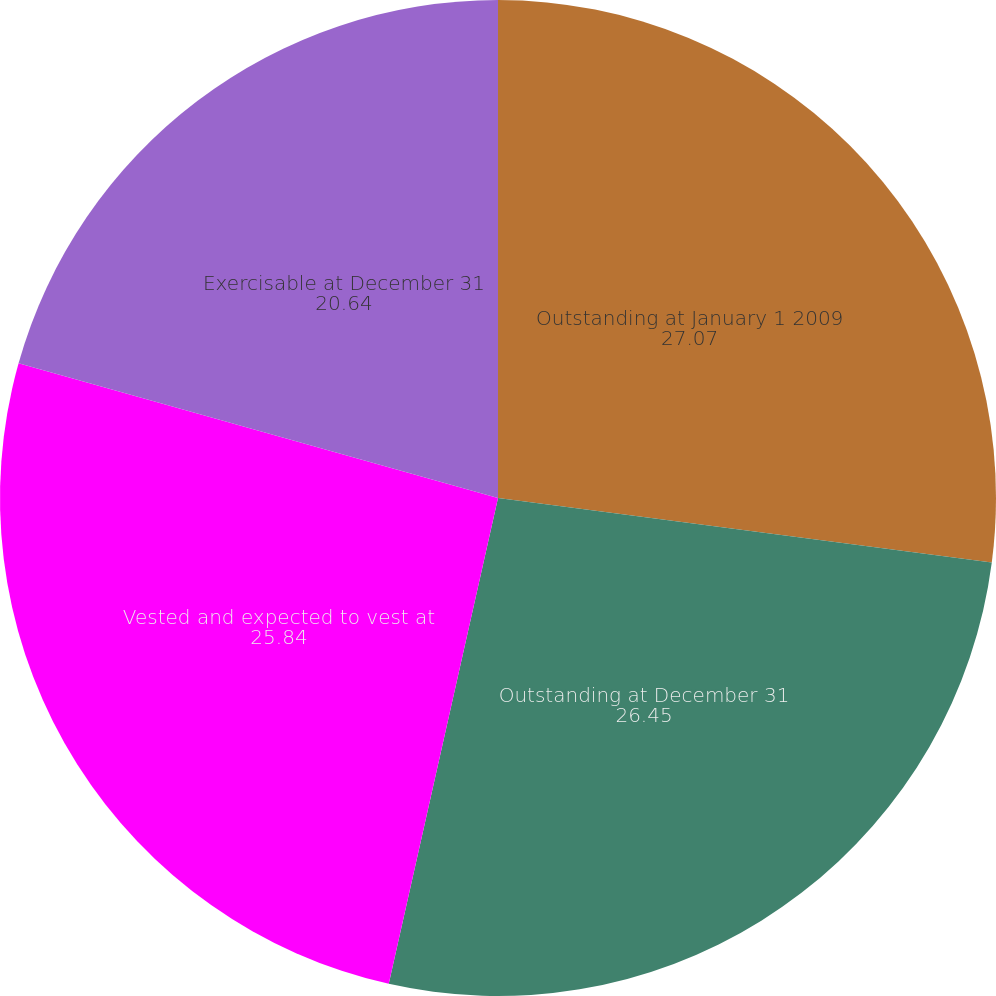Convert chart to OTSL. <chart><loc_0><loc_0><loc_500><loc_500><pie_chart><fcel>Outstanding at January 1 2009<fcel>Outstanding at December 31<fcel>Vested and expected to vest at<fcel>Exercisable at December 31<nl><fcel>27.07%<fcel>26.45%<fcel>25.84%<fcel>20.64%<nl></chart> 